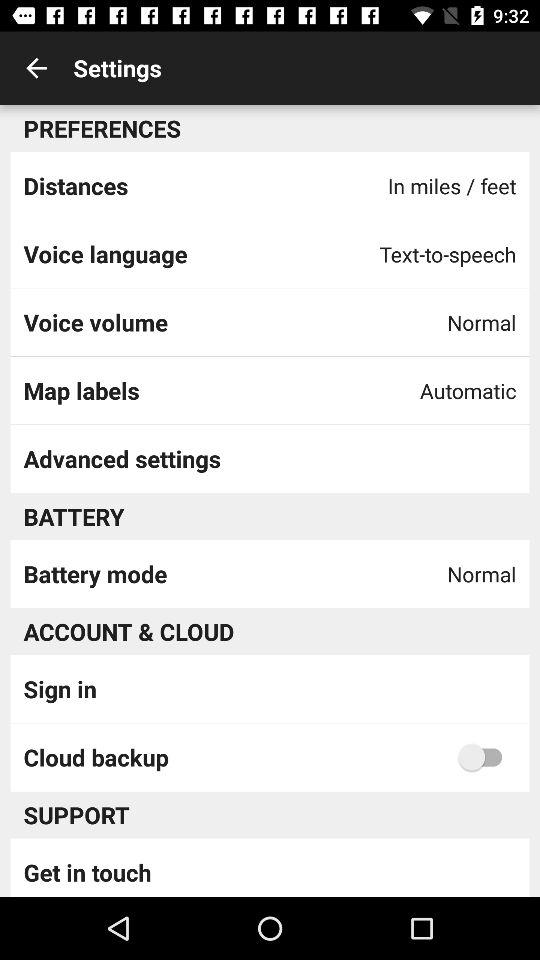What is the battery mode? The battery mode is normal. 